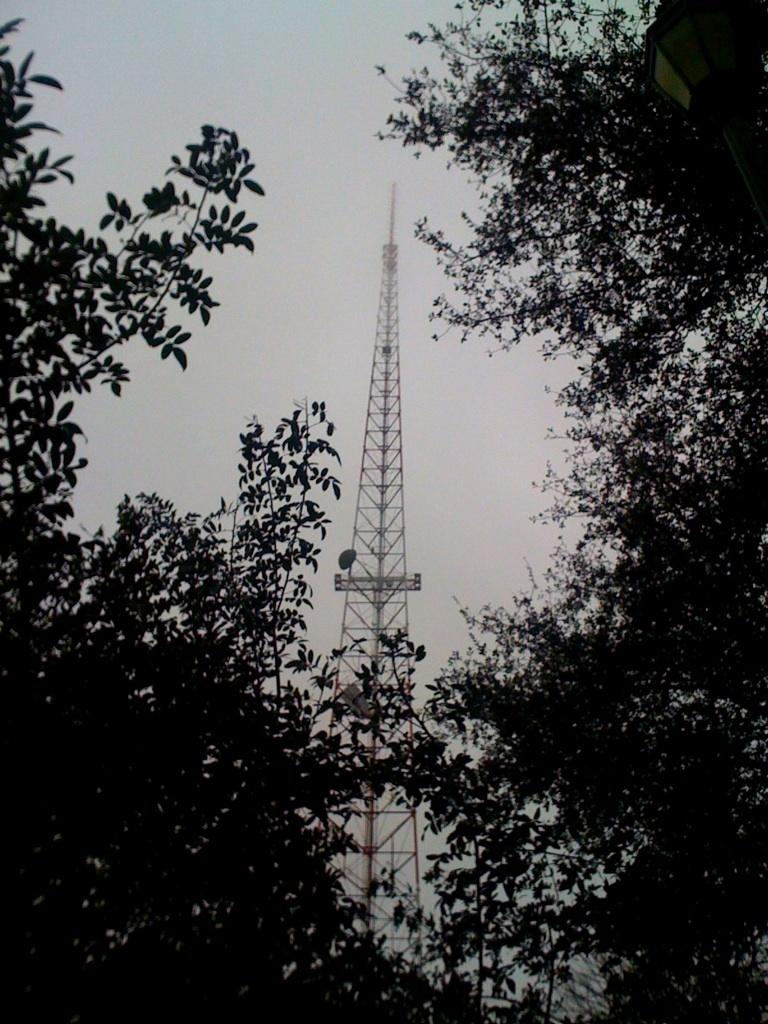What type of vegetation can be seen in the image? There are trees in the image. What structure is present in the image? There is a tower in the image. What is visible at the top of the image? The sky is visible at the top of the image. What type of lighting is present in the image? There is a street light at the top right of the image. Who is the owner of the worm in the image? There is no worm present in the image, so it is not possible to determine the owner. 